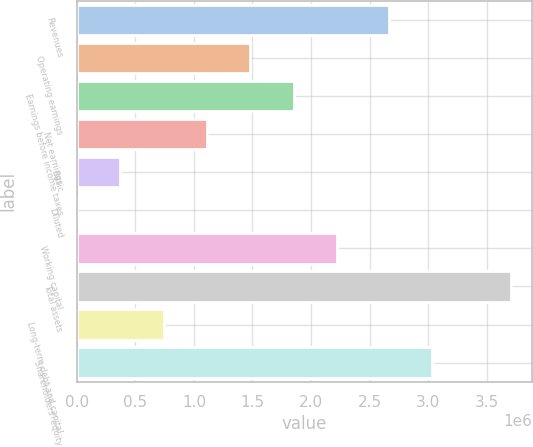Convert chart to OTSL. <chart><loc_0><loc_0><loc_500><loc_500><bar_chart><fcel>Revenues<fcel>Operating earnings<fcel>Earnings before income taxes<fcel>Net earnings<fcel>Basic<fcel>Diluted<fcel>Working capital<fcel>Total assets<fcel>Long-term debt and capital<fcel>Shareholders' equity<nl><fcel>2.66544e+06<fcel>1.48179e+06<fcel>1.85223e+06<fcel>1.11134e+06<fcel>370448<fcel>1.13<fcel>2.22268e+06<fcel>3.70447e+06<fcel>740895<fcel>3.03588e+06<nl></chart> 